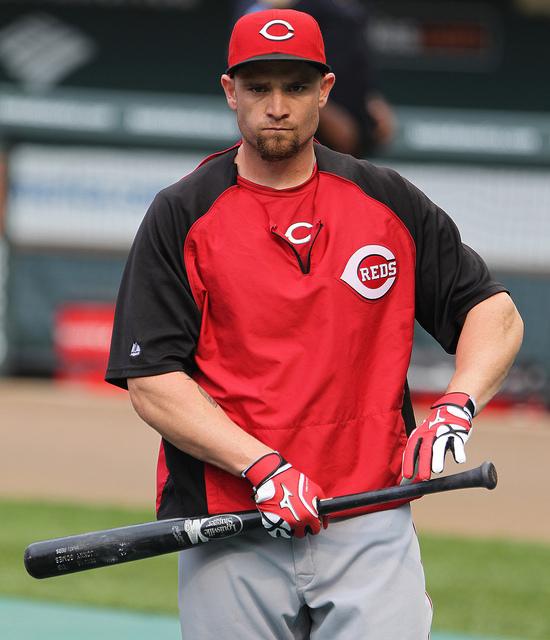Is this a major league baseball player?
Keep it brief. Yes. Who does this man play for?
Quick response, please. Reds. Which is his Jersey written?
Short answer required. Reds. 